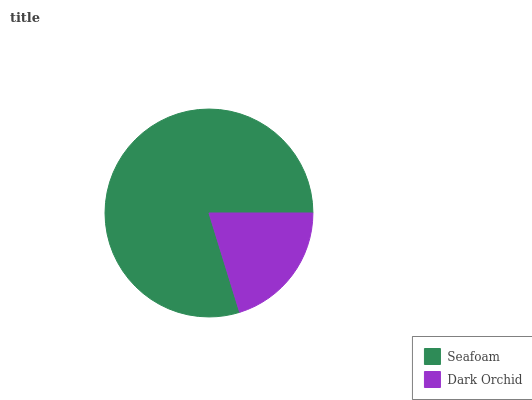Is Dark Orchid the minimum?
Answer yes or no. Yes. Is Seafoam the maximum?
Answer yes or no. Yes. Is Dark Orchid the maximum?
Answer yes or no. No. Is Seafoam greater than Dark Orchid?
Answer yes or no. Yes. Is Dark Orchid less than Seafoam?
Answer yes or no. Yes. Is Dark Orchid greater than Seafoam?
Answer yes or no. No. Is Seafoam less than Dark Orchid?
Answer yes or no. No. Is Seafoam the high median?
Answer yes or no. Yes. Is Dark Orchid the low median?
Answer yes or no. Yes. Is Dark Orchid the high median?
Answer yes or no. No. Is Seafoam the low median?
Answer yes or no. No. 